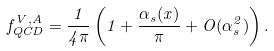Convert formula to latex. <formula><loc_0><loc_0><loc_500><loc_500>f _ { Q C D } ^ { V , A } = \frac { 1 } { 4 \pi } \left ( 1 + \frac { \alpha _ { s } ( x ) } { \pi } + O ( \alpha _ { s } ^ { 2 } ) \right ) .</formula> 